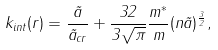Convert formula to latex. <formula><loc_0><loc_0><loc_500><loc_500>k _ { i n t } ( { r } ) = \frac { \tilde { a } } { \tilde { a } _ { c r } } + \frac { 3 2 } { 3 \sqrt { \pi } } \frac { m ^ { * } } { m } ( n \tilde { a } ) ^ { \frac { 3 } { 2 } } ,</formula> 